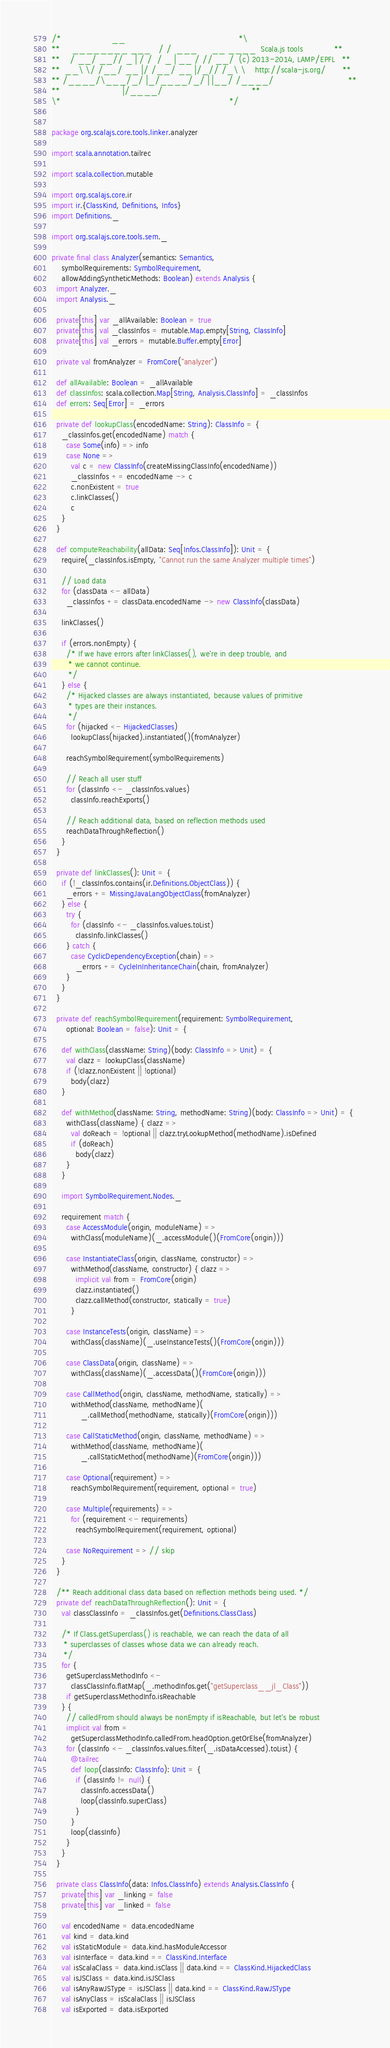Convert code to text. <code><loc_0><loc_0><loc_500><loc_500><_Scala_>/*                     __                                               *\
**     ________ ___   / /  ___      __ ____  Scala.js tools             **
**    / __/ __// _ | / /  / _ | __ / // __/  (c) 2013-2014, LAMP/EPFL   **
**  __\ \/ /__/ __ |/ /__/ __ |/_// /_\ \    http://scala-js.org/       **
** /____/\___/_/ |_/____/_/ | |__/ /____/                               **
**                          |/____/                                     **
\*                                                                      */


package org.scalajs.core.tools.linker.analyzer

import scala.annotation.tailrec

import scala.collection.mutable

import org.scalajs.core.ir
import ir.{ClassKind, Definitions, Infos}
import Definitions._

import org.scalajs.core.tools.sem._

private final class Analyzer(semantics: Semantics,
    symbolRequirements: SymbolRequirement,
    allowAddingSyntheticMethods: Boolean) extends Analysis {
  import Analyzer._
  import Analysis._

  private[this] var _allAvailable: Boolean = true
  private[this] val _classInfos = mutable.Map.empty[String, ClassInfo]
  private[this] val _errors = mutable.Buffer.empty[Error]

  private val fromAnalyzer = FromCore("analyzer")

  def allAvailable: Boolean = _allAvailable
  def classInfos: scala.collection.Map[String, Analysis.ClassInfo] = _classInfos
  def errors: Seq[Error] = _errors

  private def lookupClass(encodedName: String): ClassInfo = {
    _classInfos.get(encodedName) match {
      case Some(info) => info
      case None =>
        val c = new ClassInfo(createMissingClassInfo(encodedName))
        _classInfos += encodedName -> c
        c.nonExistent = true
        c.linkClasses()
        c
    }
  }

  def computeReachability(allData: Seq[Infos.ClassInfo]): Unit = {
    require(_classInfos.isEmpty, "Cannot run the same Analyzer multiple times")

    // Load data
    for (classData <- allData)
      _classInfos += classData.encodedName -> new ClassInfo(classData)

    linkClasses()

    if (errors.nonEmpty) {
      /* If we have errors after linkClasses(), we're in deep trouble, and
       * we cannot continue.
       */
    } else {
      /* Hijacked classes are always instantiated, because values of primitive
       * types are their instances.
       */
      for (hijacked <- HijackedClasses)
        lookupClass(hijacked).instantiated()(fromAnalyzer)

      reachSymbolRequirement(symbolRequirements)

      // Reach all user stuff
      for (classInfo <- _classInfos.values)
        classInfo.reachExports()

      // Reach additional data, based on reflection methods used
      reachDataThroughReflection()
    }
  }

  private def linkClasses(): Unit = {
    if (!_classInfos.contains(ir.Definitions.ObjectClass)) {
      _errors += MissingJavaLangObjectClass(fromAnalyzer)
    } else {
      try {
        for (classInfo <- _classInfos.values.toList)
          classInfo.linkClasses()
      } catch {
        case CyclicDependencyException(chain) =>
          _errors += CycleInInheritanceChain(chain, fromAnalyzer)
      }
    }
  }

  private def reachSymbolRequirement(requirement: SymbolRequirement,
      optional: Boolean = false): Unit = {

    def withClass(className: String)(body: ClassInfo => Unit) = {
      val clazz = lookupClass(className)
      if (!clazz.nonExistent || !optional)
        body(clazz)
    }

    def withMethod(className: String, methodName: String)(body: ClassInfo => Unit) = {
      withClass(className) { clazz =>
        val doReach = !optional || clazz.tryLookupMethod(methodName).isDefined
        if (doReach)
          body(clazz)
      }
    }

    import SymbolRequirement.Nodes._

    requirement match {
      case AccessModule(origin, moduleName) =>
        withClass(moduleName)(_.accessModule()(FromCore(origin)))

      case InstantiateClass(origin, className, constructor) =>
        withMethod(className, constructor) { clazz =>
          implicit val from = FromCore(origin)
          clazz.instantiated()
          clazz.callMethod(constructor, statically = true)
        }

      case InstanceTests(origin, className) =>
        withClass(className)(_.useInstanceTests()(FromCore(origin)))

      case ClassData(origin, className) =>
        withClass(className)(_.accessData()(FromCore(origin)))

      case CallMethod(origin, className, methodName, statically) =>
        withMethod(className, methodName)(
            _.callMethod(methodName, statically)(FromCore(origin)))

      case CallStaticMethod(origin, className, methodName) =>
        withMethod(className, methodName)(
            _.callStaticMethod(methodName)(FromCore(origin)))

      case Optional(requirement) =>
        reachSymbolRequirement(requirement, optional = true)

      case Multiple(requirements) =>
        for (requirement <- requirements)
          reachSymbolRequirement(requirement, optional)

      case NoRequirement => // skip
    }
  }

  /** Reach additional class data based on reflection methods being used. */
  private def reachDataThroughReflection(): Unit = {
    val classClassInfo = _classInfos.get(Definitions.ClassClass)

    /* If Class.getSuperclass() is reachable, we can reach the data of all
     * superclasses of classes whose data we can already reach.
     */
    for {
      getSuperclassMethodInfo <-
        classClassInfo.flatMap(_.methodInfos.get("getSuperclass__jl_Class"))
      if getSuperclassMethodInfo.isReachable
    } {
      // calledFrom should always be nonEmpty if isReachable, but let's be robust
      implicit val from =
        getSuperclassMethodInfo.calledFrom.headOption.getOrElse(fromAnalyzer)
      for (classInfo <- _classInfos.values.filter(_.isDataAccessed).toList) {
        @tailrec
        def loop(classInfo: ClassInfo): Unit = {
          if (classInfo != null) {
            classInfo.accessData()
            loop(classInfo.superClass)
          }
        }
        loop(classInfo)
      }
    }
  }

  private class ClassInfo(data: Infos.ClassInfo) extends Analysis.ClassInfo {
    private[this] var _linking = false
    private[this] var _linked = false

    val encodedName = data.encodedName
    val kind = data.kind
    val isStaticModule = data.kind.hasModuleAccessor
    val isInterface = data.kind == ClassKind.Interface
    val isScalaClass = data.kind.isClass || data.kind == ClassKind.HijackedClass
    val isJSClass = data.kind.isJSClass
    val isAnyRawJSType = isJSClass || data.kind == ClassKind.RawJSType
    val isAnyClass = isScalaClass || isJSClass
    val isExported = data.isExported
</code> 